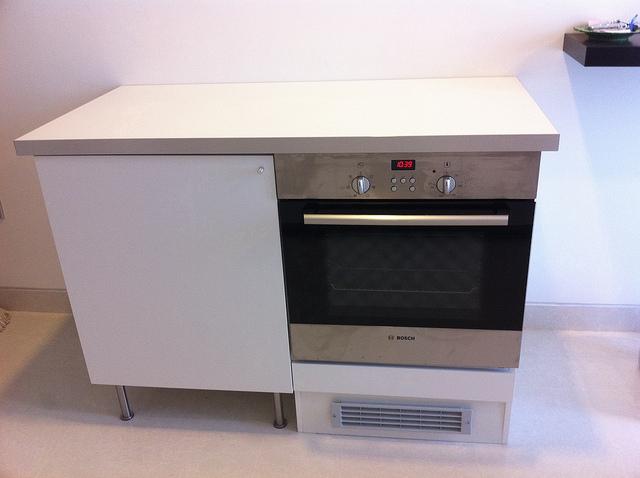What type of appliance is pictured?
Keep it brief. Oven. What do the numbers, in red, indicate?
Be succinct. Time. Is this an energy-efficient appliance?
Quick response, please. Yes. 